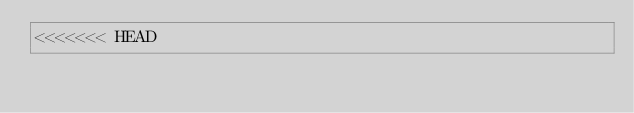<code> <loc_0><loc_0><loc_500><loc_500><_JavaScript_><<<<<<< HEAD</code> 